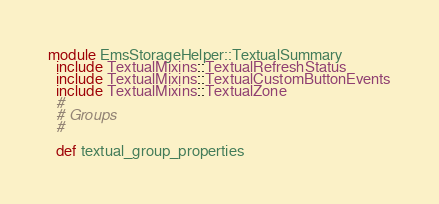<code> <loc_0><loc_0><loc_500><loc_500><_Ruby_>module EmsStorageHelper::TextualSummary
  include TextualMixins::TextualRefreshStatus
  include TextualMixins::TextualCustomButtonEvents
  include TextualMixins::TextualZone
  #
  # Groups
  #

  def textual_group_properties</code> 